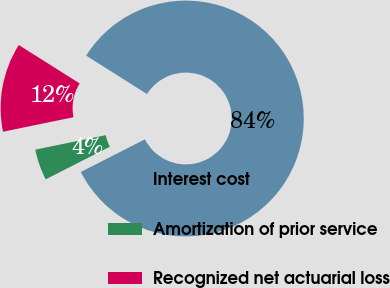<chart> <loc_0><loc_0><loc_500><loc_500><pie_chart><fcel>Interest cost<fcel>Amortization of prior service<fcel>Recognized net actuarial loss<nl><fcel>83.55%<fcel>4.26%<fcel>12.19%<nl></chart> 